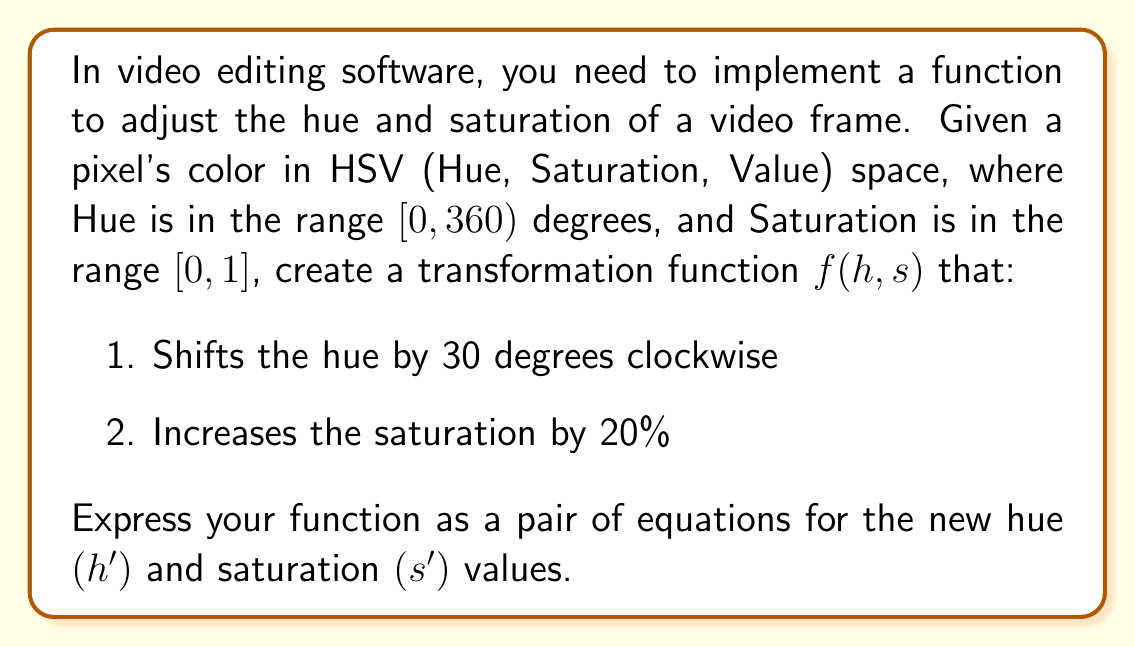Help me with this question. Let's approach this step-by-step:

1. Hue transformation:
   - We need to shift the hue by 30 degrees clockwise.
   - In HSV space, hue is circular (0-360 degrees).
   - The transformation is: $h' = h - 30$
   - However, we need to ensure the result stays in the [0, 360) range.
   - We can use the modulo operation to wrap around:
     $h' = (h - 30 + 360) \bmod 360$

2. Saturation transformation:
   - We need to increase saturation by 20%.
   - This means multiplying the current saturation by 1.2.
   - The transformation is: $s' = s \times 1.2$
   - However, we need to ensure the result stays in the [0, 1] range.
   - We can use the min function to cap the maximum value at 1:
     $s' = \min(s \times 1.2, 1)$

Combining these transformations, our function $f(h, s)$ can be expressed as:

$$f(h, s) = \begin{cases}
h' = (h - 30 + 360) \bmod 360 \\
s' = \min(s \times 1.2, 1)
\end{cases}$$
Answer: $h' = (h - 30 + 360) \bmod 360$, $s' = \min(s \times 1.2, 1)$ 